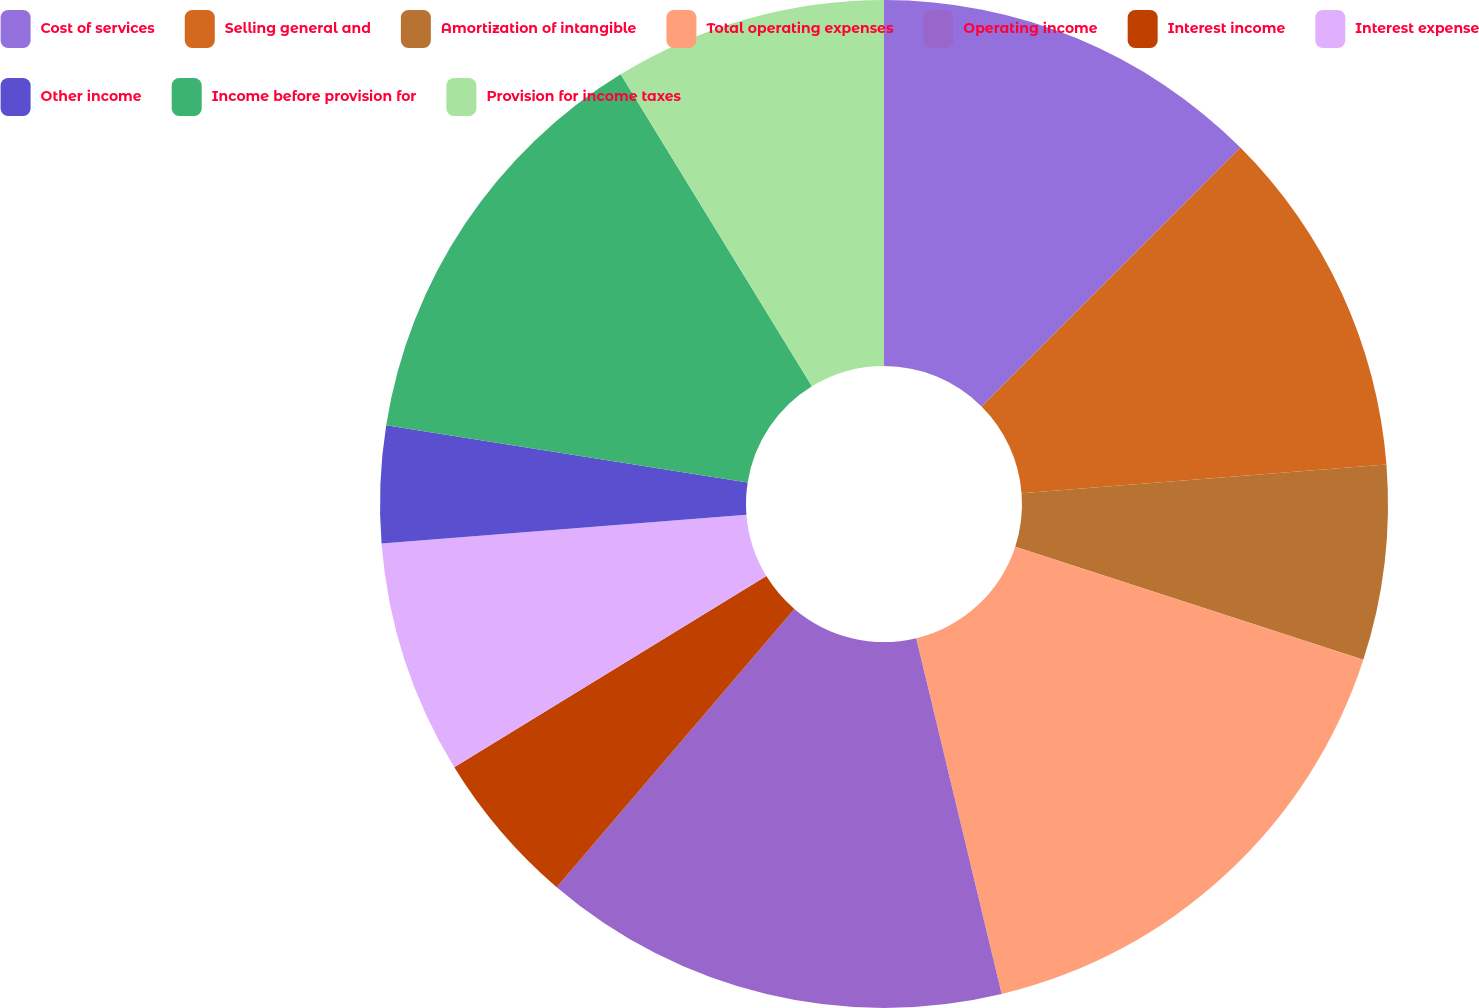Convert chart to OTSL. <chart><loc_0><loc_0><loc_500><loc_500><pie_chart><fcel>Cost of services<fcel>Selling general and<fcel>Amortization of intangible<fcel>Total operating expenses<fcel>Operating income<fcel>Interest income<fcel>Interest expense<fcel>Other income<fcel>Income before provision for<fcel>Provision for income taxes<nl><fcel>12.5%<fcel>11.25%<fcel>6.25%<fcel>16.25%<fcel>15.0%<fcel>5.0%<fcel>7.5%<fcel>3.75%<fcel>13.75%<fcel>8.75%<nl></chart> 